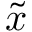Convert formula to latex. <formula><loc_0><loc_0><loc_500><loc_500>\tilde { x }</formula> 